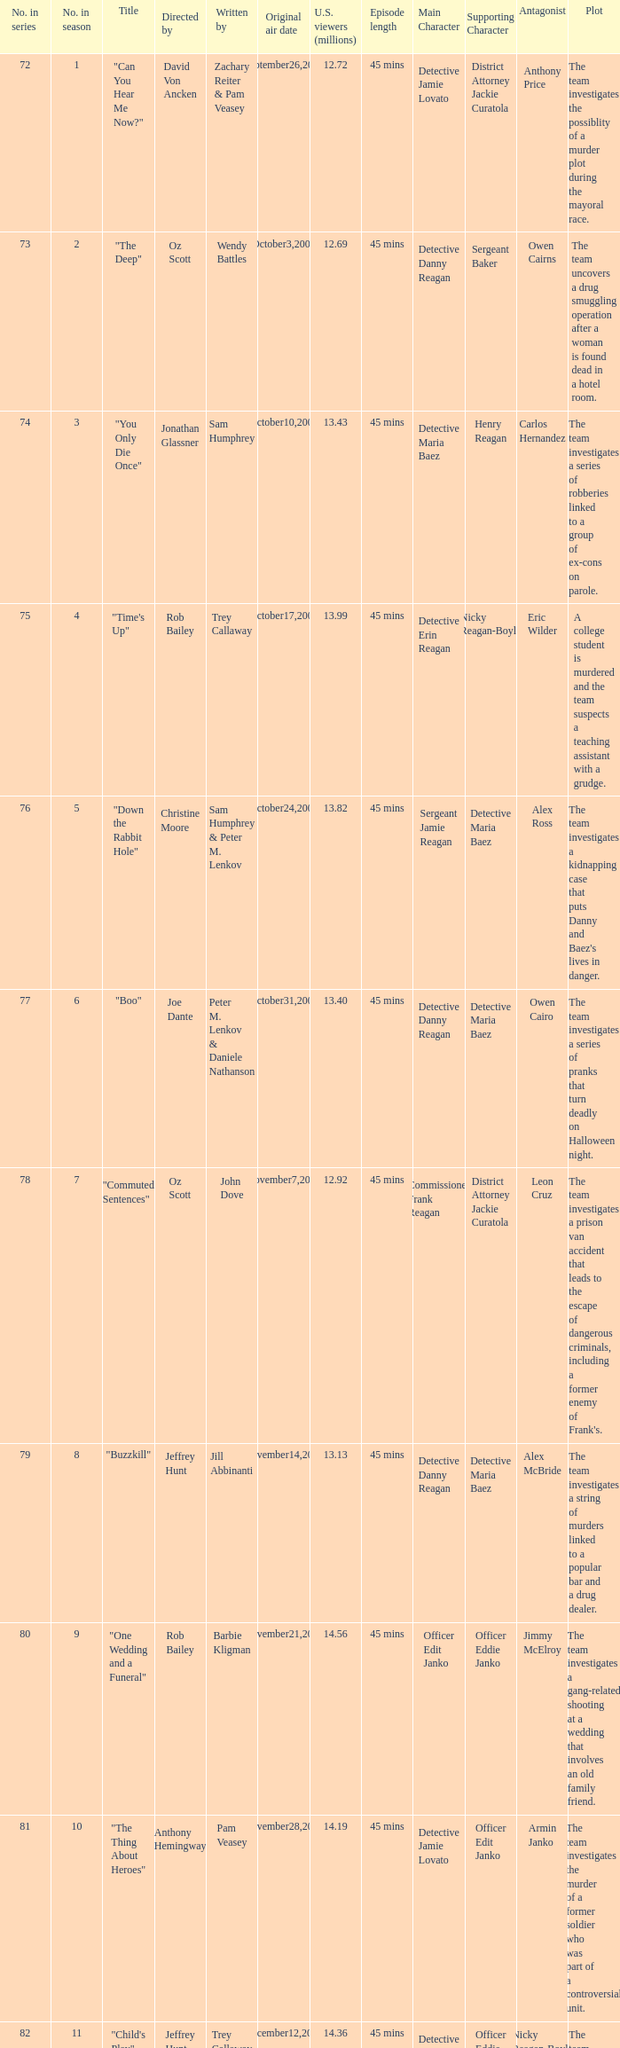How many episodes were watched by 12.72 million U.S. viewers? 1.0. 